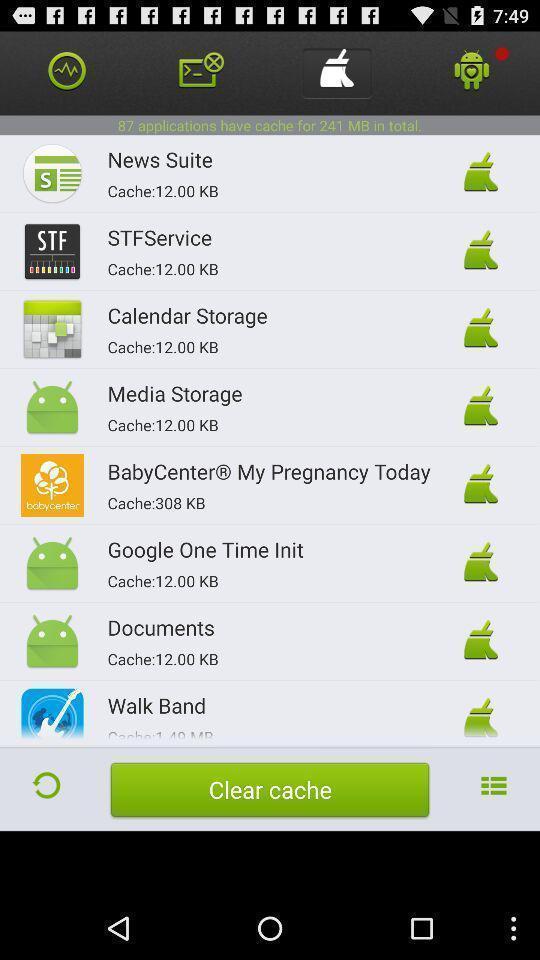Explain the elements present in this screenshot. Page displaying to clear the cache of all apllications. 